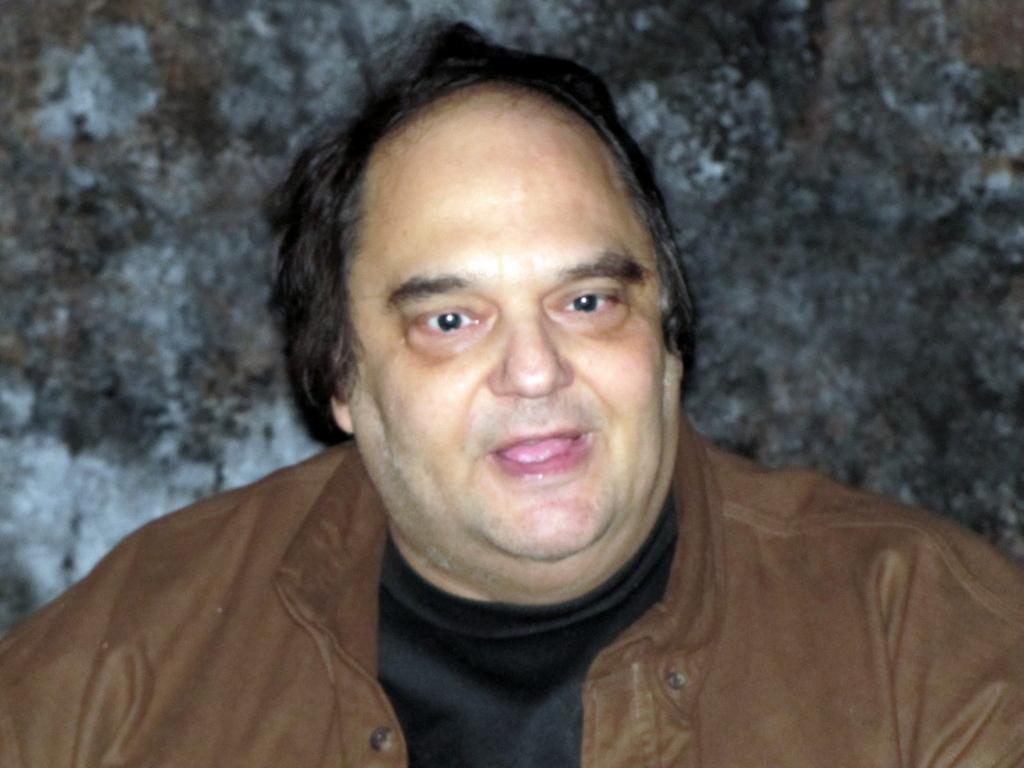How would you summarize this image in a sentence or two? In this image, we can see a man wearing a brown color jacket. In the background, we can see black color. 